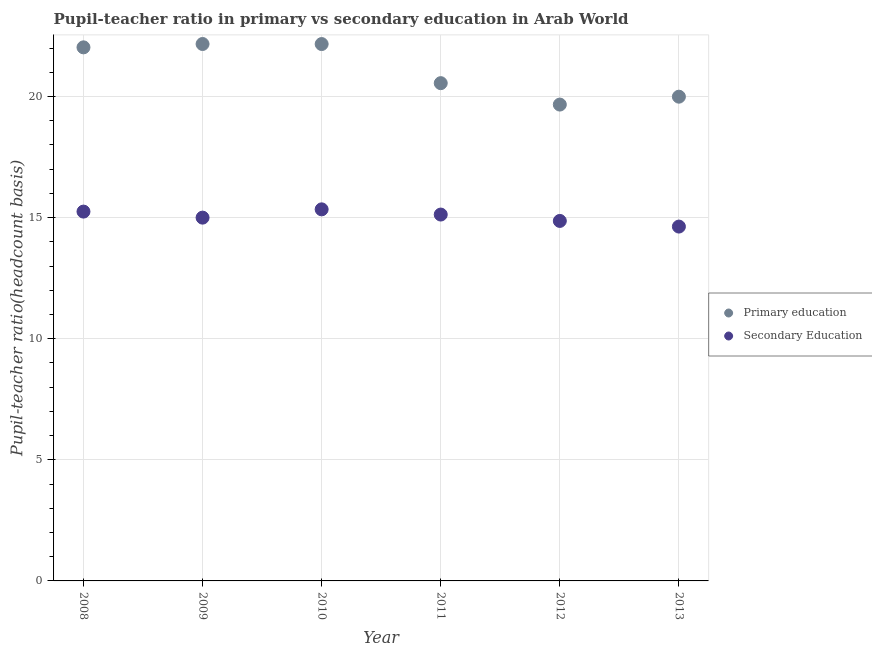How many different coloured dotlines are there?
Offer a very short reply. 2. What is the pupil teacher ratio on secondary education in 2010?
Offer a terse response. 15.34. Across all years, what is the maximum pupil-teacher ratio in primary education?
Offer a very short reply. 22.17. Across all years, what is the minimum pupil-teacher ratio in primary education?
Offer a terse response. 19.67. In which year was the pupil-teacher ratio in primary education maximum?
Your response must be concise. 2009. In which year was the pupil-teacher ratio in primary education minimum?
Give a very brief answer. 2012. What is the total pupil teacher ratio on secondary education in the graph?
Your answer should be very brief. 90.22. What is the difference between the pupil-teacher ratio in primary education in 2009 and that in 2013?
Your response must be concise. 2.18. What is the difference between the pupil-teacher ratio in primary education in 2012 and the pupil teacher ratio on secondary education in 2013?
Keep it short and to the point. 5.04. What is the average pupil teacher ratio on secondary education per year?
Make the answer very short. 15.04. In the year 2008, what is the difference between the pupil-teacher ratio in primary education and pupil teacher ratio on secondary education?
Your answer should be very brief. 6.78. What is the ratio of the pupil-teacher ratio in primary education in 2011 to that in 2012?
Your answer should be very brief. 1.04. Is the pupil teacher ratio on secondary education in 2008 less than that in 2009?
Your answer should be compact. No. What is the difference between the highest and the second highest pupil teacher ratio on secondary education?
Your answer should be very brief. 0.09. What is the difference between the highest and the lowest pupil teacher ratio on secondary education?
Your response must be concise. 0.71. In how many years, is the pupil-teacher ratio in primary education greater than the average pupil-teacher ratio in primary education taken over all years?
Offer a terse response. 3. Is the sum of the pupil-teacher ratio in primary education in 2009 and 2012 greater than the maximum pupil teacher ratio on secondary education across all years?
Make the answer very short. Yes. Does the pupil-teacher ratio in primary education monotonically increase over the years?
Provide a short and direct response. No. Is the pupil-teacher ratio in primary education strictly greater than the pupil teacher ratio on secondary education over the years?
Keep it short and to the point. Yes. How many years are there in the graph?
Give a very brief answer. 6. Does the graph contain grids?
Your response must be concise. Yes. Where does the legend appear in the graph?
Your answer should be very brief. Center right. How many legend labels are there?
Offer a very short reply. 2. How are the legend labels stacked?
Your answer should be very brief. Vertical. What is the title of the graph?
Provide a short and direct response. Pupil-teacher ratio in primary vs secondary education in Arab World. What is the label or title of the Y-axis?
Your answer should be very brief. Pupil-teacher ratio(headcount basis). What is the Pupil-teacher ratio(headcount basis) in Primary education in 2008?
Your response must be concise. 22.03. What is the Pupil-teacher ratio(headcount basis) of Secondary Education in 2008?
Your response must be concise. 15.25. What is the Pupil-teacher ratio(headcount basis) in Primary education in 2009?
Your answer should be very brief. 22.17. What is the Pupil-teacher ratio(headcount basis) of Secondary Education in 2009?
Keep it short and to the point. 15. What is the Pupil-teacher ratio(headcount basis) of Primary education in 2010?
Provide a short and direct response. 22.17. What is the Pupil-teacher ratio(headcount basis) of Secondary Education in 2010?
Offer a terse response. 15.34. What is the Pupil-teacher ratio(headcount basis) in Primary education in 2011?
Make the answer very short. 20.55. What is the Pupil-teacher ratio(headcount basis) in Secondary Education in 2011?
Offer a very short reply. 15.13. What is the Pupil-teacher ratio(headcount basis) in Primary education in 2012?
Provide a short and direct response. 19.67. What is the Pupil-teacher ratio(headcount basis) of Secondary Education in 2012?
Your answer should be compact. 14.86. What is the Pupil-teacher ratio(headcount basis) in Primary education in 2013?
Make the answer very short. 20. What is the Pupil-teacher ratio(headcount basis) of Secondary Education in 2013?
Provide a short and direct response. 14.63. Across all years, what is the maximum Pupil-teacher ratio(headcount basis) of Primary education?
Offer a terse response. 22.17. Across all years, what is the maximum Pupil-teacher ratio(headcount basis) of Secondary Education?
Make the answer very short. 15.34. Across all years, what is the minimum Pupil-teacher ratio(headcount basis) in Primary education?
Offer a terse response. 19.67. Across all years, what is the minimum Pupil-teacher ratio(headcount basis) in Secondary Education?
Your response must be concise. 14.63. What is the total Pupil-teacher ratio(headcount basis) of Primary education in the graph?
Offer a terse response. 126.59. What is the total Pupil-teacher ratio(headcount basis) in Secondary Education in the graph?
Your answer should be compact. 90.22. What is the difference between the Pupil-teacher ratio(headcount basis) in Primary education in 2008 and that in 2009?
Make the answer very short. -0.14. What is the difference between the Pupil-teacher ratio(headcount basis) in Secondary Education in 2008 and that in 2009?
Offer a terse response. 0.25. What is the difference between the Pupil-teacher ratio(headcount basis) of Primary education in 2008 and that in 2010?
Provide a succinct answer. -0.14. What is the difference between the Pupil-teacher ratio(headcount basis) of Secondary Education in 2008 and that in 2010?
Your response must be concise. -0.09. What is the difference between the Pupil-teacher ratio(headcount basis) of Primary education in 2008 and that in 2011?
Offer a very short reply. 1.48. What is the difference between the Pupil-teacher ratio(headcount basis) in Secondary Education in 2008 and that in 2011?
Offer a very short reply. 0.12. What is the difference between the Pupil-teacher ratio(headcount basis) in Primary education in 2008 and that in 2012?
Your answer should be very brief. 2.36. What is the difference between the Pupil-teacher ratio(headcount basis) in Secondary Education in 2008 and that in 2012?
Give a very brief answer. 0.39. What is the difference between the Pupil-teacher ratio(headcount basis) in Primary education in 2008 and that in 2013?
Keep it short and to the point. 2.04. What is the difference between the Pupil-teacher ratio(headcount basis) of Secondary Education in 2008 and that in 2013?
Your response must be concise. 0.62. What is the difference between the Pupil-teacher ratio(headcount basis) of Primary education in 2009 and that in 2010?
Your answer should be very brief. 0. What is the difference between the Pupil-teacher ratio(headcount basis) of Secondary Education in 2009 and that in 2010?
Provide a short and direct response. -0.34. What is the difference between the Pupil-teacher ratio(headcount basis) of Primary education in 2009 and that in 2011?
Your response must be concise. 1.62. What is the difference between the Pupil-teacher ratio(headcount basis) in Secondary Education in 2009 and that in 2011?
Your response must be concise. -0.13. What is the difference between the Pupil-teacher ratio(headcount basis) of Primary education in 2009 and that in 2012?
Make the answer very short. 2.5. What is the difference between the Pupil-teacher ratio(headcount basis) in Secondary Education in 2009 and that in 2012?
Your answer should be very brief. 0.14. What is the difference between the Pupil-teacher ratio(headcount basis) of Primary education in 2009 and that in 2013?
Your answer should be very brief. 2.18. What is the difference between the Pupil-teacher ratio(headcount basis) of Secondary Education in 2009 and that in 2013?
Provide a short and direct response. 0.37. What is the difference between the Pupil-teacher ratio(headcount basis) of Primary education in 2010 and that in 2011?
Ensure brevity in your answer.  1.61. What is the difference between the Pupil-teacher ratio(headcount basis) of Secondary Education in 2010 and that in 2011?
Your answer should be compact. 0.21. What is the difference between the Pupil-teacher ratio(headcount basis) of Primary education in 2010 and that in 2012?
Ensure brevity in your answer.  2.5. What is the difference between the Pupil-teacher ratio(headcount basis) in Secondary Education in 2010 and that in 2012?
Provide a short and direct response. 0.48. What is the difference between the Pupil-teacher ratio(headcount basis) of Primary education in 2010 and that in 2013?
Make the answer very short. 2.17. What is the difference between the Pupil-teacher ratio(headcount basis) in Secondary Education in 2010 and that in 2013?
Make the answer very short. 0.71. What is the difference between the Pupil-teacher ratio(headcount basis) of Primary education in 2011 and that in 2012?
Your response must be concise. 0.88. What is the difference between the Pupil-teacher ratio(headcount basis) in Secondary Education in 2011 and that in 2012?
Your answer should be compact. 0.26. What is the difference between the Pupil-teacher ratio(headcount basis) of Primary education in 2011 and that in 2013?
Provide a short and direct response. 0.56. What is the difference between the Pupil-teacher ratio(headcount basis) in Secondary Education in 2011 and that in 2013?
Offer a terse response. 0.5. What is the difference between the Pupil-teacher ratio(headcount basis) in Primary education in 2012 and that in 2013?
Provide a short and direct response. -0.33. What is the difference between the Pupil-teacher ratio(headcount basis) in Secondary Education in 2012 and that in 2013?
Your answer should be very brief. 0.23. What is the difference between the Pupil-teacher ratio(headcount basis) of Primary education in 2008 and the Pupil-teacher ratio(headcount basis) of Secondary Education in 2009?
Provide a succinct answer. 7.03. What is the difference between the Pupil-teacher ratio(headcount basis) of Primary education in 2008 and the Pupil-teacher ratio(headcount basis) of Secondary Education in 2010?
Give a very brief answer. 6.69. What is the difference between the Pupil-teacher ratio(headcount basis) of Primary education in 2008 and the Pupil-teacher ratio(headcount basis) of Secondary Education in 2011?
Keep it short and to the point. 6.9. What is the difference between the Pupil-teacher ratio(headcount basis) in Primary education in 2008 and the Pupil-teacher ratio(headcount basis) in Secondary Education in 2012?
Provide a succinct answer. 7.17. What is the difference between the Pupil-teacher ratio(headcount basis) of Primary education in 2008 and the Pupil-teacher ratio(headcount basis) of Secondary Education in 2013?
Your answer should be very brief. 7.4. What is the difference between the Pupil-teacher ratio(headcount basis) in Primary education in 2009 and the Pupil-teacher ratio(headcount basis) in Secondary Education in 2010?
Offer a terse response. 6.83. What is the difference between the Pupil-teacher ratio(headcount basis) in Primary education in 2009 and the Pupil-teacher ratio(headcount basis) in Secondary Education in 2011?
Keep it short and to the point. 7.04. What is the difference between the Pupil-teacher ratio(headcount basis) of Primary education in 2009 and the Pupil-teacher ratio(headcount basis) of Secondary Education in 2012?
Your response must be concise. 7.31. What is the difference between the Pupil-teacher ratio(headcount basis) in Primary education in 2009 and the Pupil-teacher ratio(headcount basis) in Secondary Education in 2013?
Provide a succinct answer. 7.54. What is the difference between the Pupil-teacher ratio(headcount basis) in Primary education in 2010 and the Pupil-teacher ratio(headcount basis) in Secondary Education in 2011?
Make the answer very short. 7.04. What is the difference between the Pupil-teacher ratio(headcount basis) of Primary education in 2010 and the Pupil-teacher ratio(headcount basis) of Secondary Education in 2012?
Provide a succinct answer. 7.3. What is the difference between the Pupil-teacher ratio(headcount basis) of Primary education in 2010 and the Pupil-teacher ratio(headcount basis) of Secondary Education in 2013?
Your response must be concise. 7.54. What is the difference between the Pupil-teacher ratio(headcount basis) of Primary education in 2011 and the Pupil-teacher ratio(headcount basis) of Secondary Education in 2012?
Your answer should be compact. 5.69. What is the difference between the Pupil-teacher ratio(headcount basis) in Primary education in 2011 and the Pupil-teacher ratio(headcount basis) in Secondary Education in 2013?
Provide a short and direct response. 5.92. What is the difference between the Pupil-teacher ratio(headcount basis) of Primary education in 2012 and the Pupil-teacher ratio(headcount basis) of Secondary Education in 2013?
Offer a terse response. 5.04. What is the average Pupil-teacher ratio(headcount basis) of Primary education per year?
Make the answer very short. 21.1. What is the average Pupil-teacher ratio(headcount basis) of Secondary Education per year?
Offer a terse response. 15.04. In the year 2008, what is the difference between the Pupil-teacher ratio(headcount basis) in Primary education and Pupil-teacher ratio(headcount basis) in Secondary Education?
Ensure brevity in your answer.  6.78. In the year 2009, what is the difference between the Pupil-teacher ratio(headcount basis) in Primary education and Pupil-teacher ratio(headcount basis) in Secondary Education?
Make the answer very short. 7.17. In the year 2010, what is the difference between the Pupil-teacher ratio(headcount basis) of Primary education and Pupil-teacher ratio(headcount basis) of Secondary Education?
Make the answer very short. 6.83. In the year 2011, what is the difference between the Pupil-teacher ratio(headcount basis) of Primary education and Pupil-teacher ratio(headcount basis) of Secondary Education?
Ensure brevity in your answer.  5.43. In the year 2012, what is the difference between the Pupil-teacher ratio(headcount basis) of Primary education and Pupil-teacher ratio(headcount basis) of Secondary Education?
Provide a succinct answer. 4.8. In the year 2013, what is the difference between the Pupil-teacher ratio(headcount basis) of Primary education and Pupil-teacher ratio(headcount basis) of Secondary Education?
Your answer should be compact. 5.36. What is the ratio of the Pupil-teacher ratio(headcount basis) of Secondary Education in 2008 to that in 2009?
Give a very brief answer. 1.02. What is the ratio of the Pupil-teacher ratio(headcount basis) in Primary education in 2008 to that in 2011?
Offer a terse response. 1.07. What is the ratio of the Pupil-teacher ratio(headcount basis) of Secondary Education in 2008 to that in 2011?
Keep it short and to the point. 1.01. What is the ratio of the Pupil-teacher ratio(headcount basis) in Primary education in 2008 to that in 2012?
Offer a terse response. 1.12. What is the ratio of the Pupil-teacher ratio(headcount basis) of Secondary Education in 2008 to that in 2012?
Offer a terse response. 1.03. What is the ratio of the Pupil-teacher ratio(headcount basis) of Primary education in 2008 to that in 2013?
Give a very brief answer. 1.1. What is the ratio of the Pupil-teacher ratio(headcount basis) in Secondary Education in 2008 to that in 2013?
Offer a very short reply. 1.04. What is the ratio of the Pupil-teacher ratio(headcount basis) in Secondary Education in 2009 to that in 2010?
Give a very brief answer. 0.98. What is the ratio of the Pupil-teacher ratio(headcount basis) in Primary education in 2009 to that in 2011?
Your answer should be very brief. 1.08. What is the ratio of the Pupil-teacher ratio(headcount basis) in Secondary Education in 2009 to that in 2011?
Make the answer very short. 0.99. What is the ratio of the Pupil-teacher ratio(headcount basis) of Primary education in 2009 to that in 2012?
Make the answer very short. 1.13. What is the ratio of the Pupil-teacher ratio(headcount basis) of Secondary Education in 2009 to that in 2012?
Give a very brief answer. 1.01. What is the ratio of the Pupil-teacher ratio(headcount basis) of Primary education in 2009 to that in 2013?
Make the answer very short. 1.11. What is the ratio of the Pupil-teacher ratio(headcount basis) of Secondary Education in 2009 to that in 2013?
Your answer should be very brief. 1.03. What is the ratio of the Pupil-teacher ratio(headcount basis) of Primary education in 2010 to that in 2011?
Your answer should be very brief. 1.08. What is the ratio of the Pupil-teacher ratio(headcount basis) in Secondary Education in 2010 to that in 2011?
Offer a very short reply. 1.01. What is the ratio of the Pupil-teacher ratio(headcount basis) in Primary education in 2010 to that in 2012?
Offer a very short reply. 1.13. What is the ratio of the Pupil-teacher ratio(headcount basis) of Secondary Education in 2010 to that in 2012?
Your response must be concise. 1.03. What is the ratio of the Pupil-teacher ratio(headcount basis) in Primary education in 2010 to that in 2013?
Provide a succinct answer. 1.11. What is the ratio of the Pupil-teacher ratio(headcount basis) of Secondary Education in 2010 to that in 2013?
Your response must be concise. 1.05. What is the ratio of the Pupil-teacher ratio(headcount basis) in Primary education in 2011 to that in 2012?
Make the answer very short. 1.04. What is the ratio of the Pupil-teacher ratio(headcount basis) in Secondary Education in 2011 to that in 2012?
Your answer should be very brief. 1.02. What is the ratio of the Pupil-teacher ratio(headcount basis) of Primary education in 2011 to that in 2013?
Ensure brevity in your answer.  1.03. What is the ratio of the Pupil-teacher ratio(headcount basis) in Secondary Education in 2011 to that in 2013?
Ensure brevity in your answer.  1.03. What is the ratio of the Pupil-teacher ratio(headcount basis) in Primary education in 2012 to that in 2013?
Your answer should be very brief. 0.98. What is the ratio of the Pupil-teacher ratio(headcount basis) of Secondary Education in 2012 to that in 2013?
Your response must be concise. 1.02. What is the difference between the highest and the second highest Pupil-teacher ratio(headcount basis) of Primary education?
Your answer should be compact. 0. What is the difference between the highest and the second highest Pupil-teacher ratio(headcount basis) of Secondary Education?
Your answer should be compact. 0.09. What is the difference between the highest and the lowest Pupil-teacher ratio(headcount basis) of Primary education?
Ensure brevity in your answer.  2.5. What is the difference between the highest and the lowest Pupil-teacher ratio(headcount basis) of Secondary Education?
Ensure brevity in your answer.  0.71. 